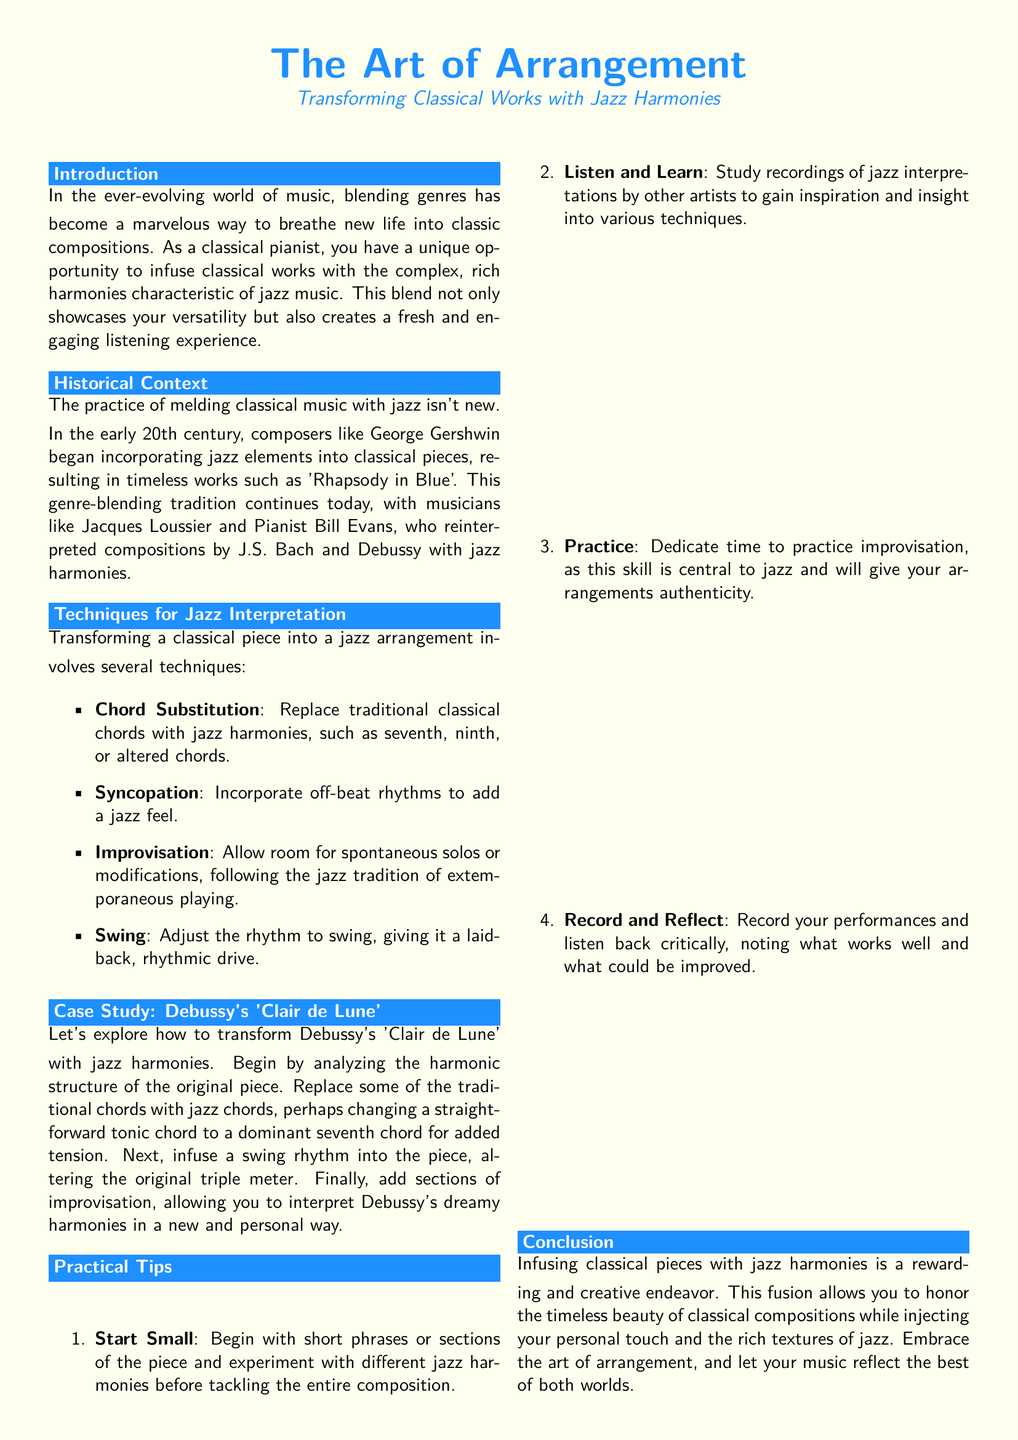What is the main theme of the document? The document discusses the blending of classical music with jazz, highlighting techniques and historical context.
Answer: The Art of Arrangement Who is mentioned as a composer associated with blending jazz and classical music? George Gershwin is noted for incorporating jazz elements into classical works.
Answer: George Gershwin What is one technique suggested for jazz interpretation? The document lists several techniques for transforming classical pieces, highlighting the diversity of approaches.
Answer: Chord Substitution Which classical piece is used as a case study in the document? The case study focuses on a well-known composition by Debussy that can be transformed with jazz harmonies.
Answer: Clair de Lune What is one practical tip provided for musicians in the document? The text offers practical advice to help musicians effectively blend genres, underscoring the learning process involved.
Answer: Start Small When did the practice of melding classical and jazz music begin? The document indicates that this blending tradition started in the early 20th century.
Answer: Early 20th century What is the purpose of the document? The main goal is to inspire classical pianists to explore jazz harmonies within classical works.
Answer: To inspire classical pianists Which notable jazz musicians are mentioned in the historical context section? A couple of influential musicians in this genre-blending tradition is referenced in the document.
Answer: Jacques Loussier and Bill Evans What color is used as a background for the document? The color for the background is specified at the beginning of the document to set a thematic tone.
Answer: Soft ivory 